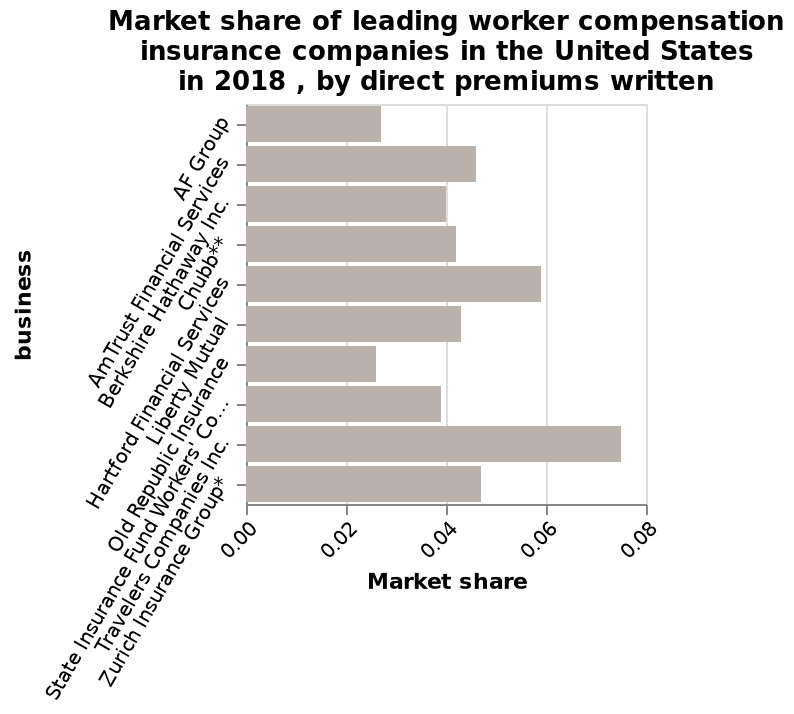<image>
What year does the market share data in the bar diagram represent? The market share data in the bar diagram represents the year 2018. Who has the smallest market share according to the chart? AF group. please enumerates aspects of the construction of the chart Market share of leading worker compensation insurance companies in the United States in 2018 , by direct premiums written is a bar diagram. business is drawn along the y-axis. There is a linear scale of range 0.00 to 0.08 on the x-axis, labeled Market share. 